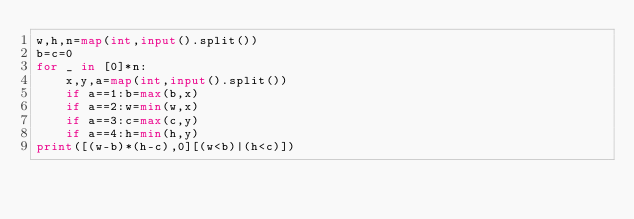<code> <loc_0><loc_0><loc_500><loc_500><_Python_>w,h,n=map(int,input().split())
b=c=0
for _ in [0]*n:
    x,y,a=map(int,input().split())
    if a==1:b=max(b,x)
    if a==2:w=min(w,x)
    if a==3:c=max(c,y)
    if a==4:h=min(h,y)
print([(w-b)*(h-c),0][(w<b)|(h<c)])</code> 